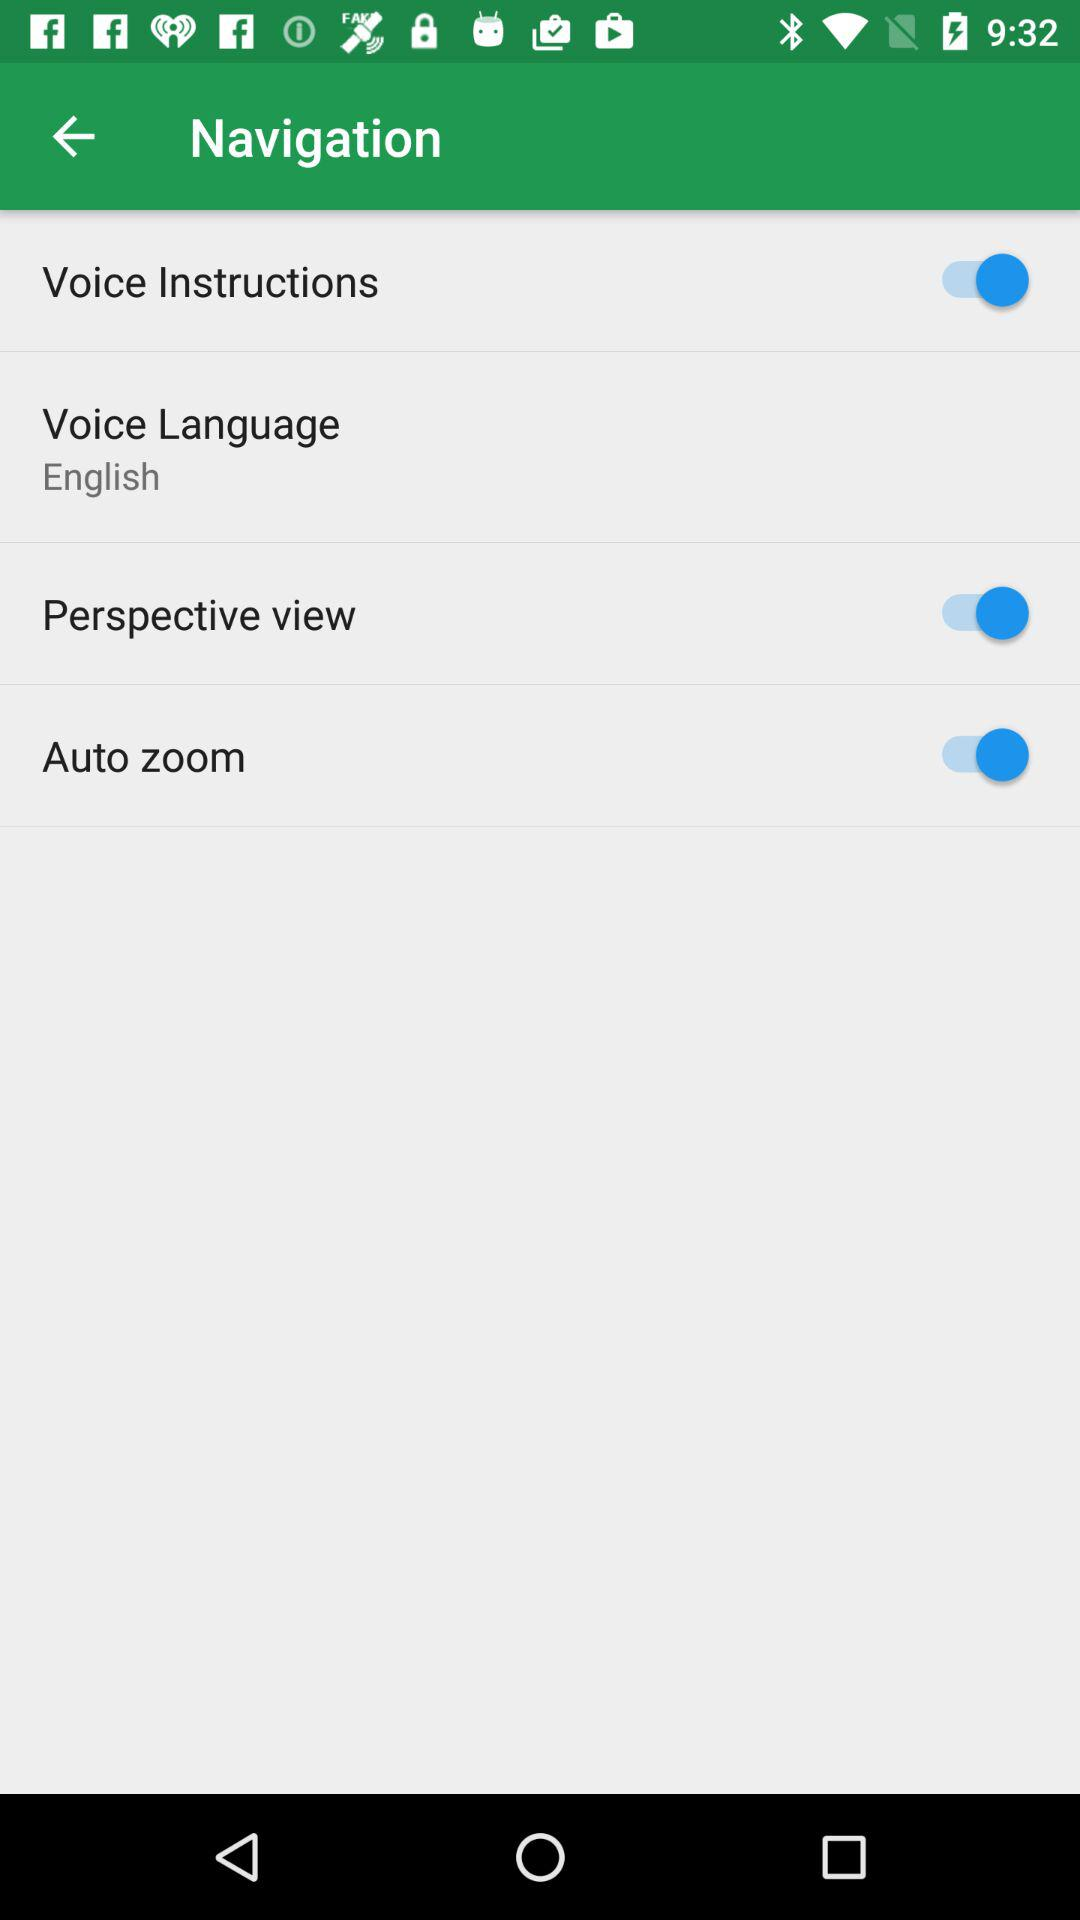What is the status of the perspective view? The status of the perspective is on. 